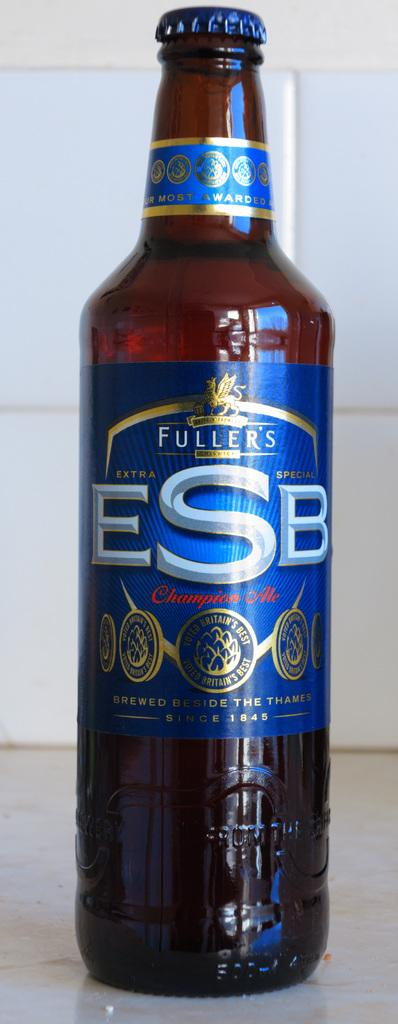<image>
Share a concise interpretation of the image provided. Fuller's ESP Champion Ale Beer that is voted Britian's Best. 